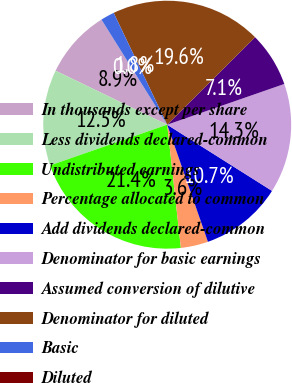Convert chart. <chart><loc_0><loc_0><loc_500><loc_500><pie_chart><fcel>In thousands except per share<fcel>Less dividends declared-common<fcel>Undistributed earnings<fcel>Percentage allocated to common<fcel>Add dividends declared-common<fcel>Denominator for basic earnings<fcel>Assumed conversion of dilutive<fcel>Denominator for diluted<fcel>Basic<fcel>Diluted<nl><fcel>8.93%<fcel>12.5%<fcel>21.43%<fcel>3.57%<fcel>10.71%<fcel>14.29%<fcel>7.14%<fcel>19.64%<fcel>1.79%<fcel>0.0%<nl></chart> 